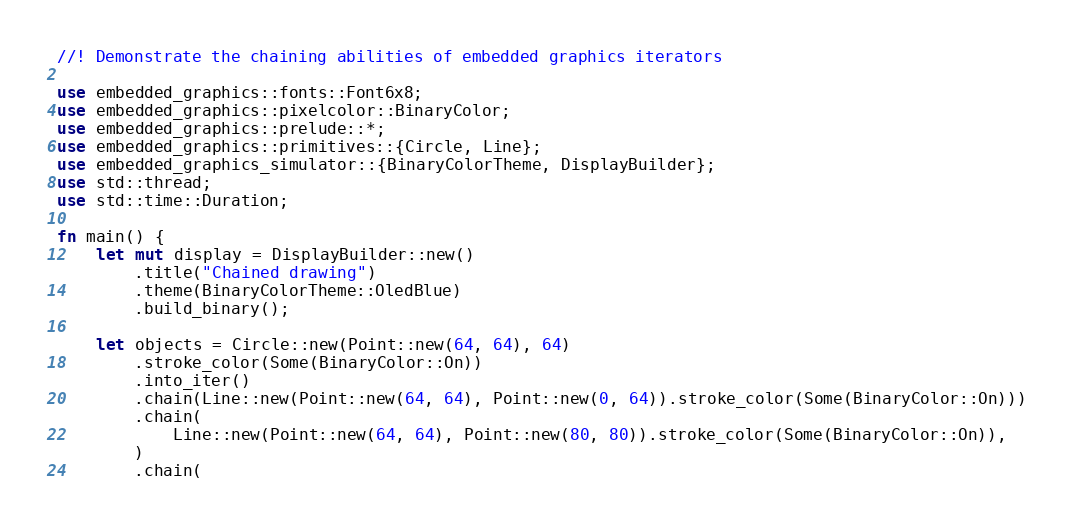<code> <loc_0><loc_0><loc_500><loc_500><_Rust_>//! Demonstrate the chaining abilities of embedded graphics iterators

use embedded_graphics::fonts::Font6x8;
use embedded_graphics::pixelcolor::BinaryColor;
use embedded_graphics::prelude::*;
use embedded_graphics::primitives::{Circle, Line};
use embedded_graphics_simulator::{BinaryColorTheme, DisplayBuilder};
use std::thread;
use std::time::Duration;

fn main() {
    let mut display = DisplayBuilder::new()
        .title("Chained drawing")
        .theme(BinaryColorTheme::OledBlue)
        .build_binary();

    let objects = Circle::new(Point::new(64, 64), 64)
        .stroke_color(Some(BinaryColor::On))
        .into_iter()
        .chain(Line::new(Point::new(64, 64), Point::new(0, 64)).stroke_color(Some(BinaryColor::On)))
        .chain(
            Line::new(Point::new(64, 64), Point::new(80, 80)).stroke_color(Some(BinaryColor::On)),
        )
        .chain(</code> 